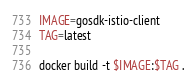<code> <loc_0><loc_0><loc_500><loc_500><_Bash_>IMAGE=gosdk-istio-client
TAG=latest

docker build -t $IMAGE:$TAG .
</code> 